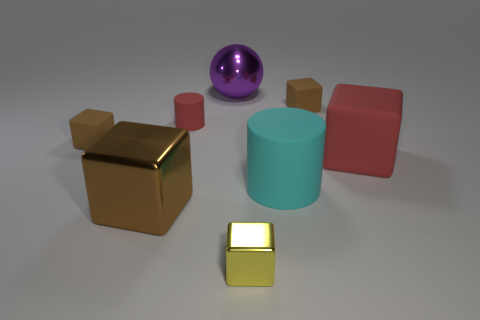Subtract all large rubber blocks. How many blocks are left? 4 Subtract all yellow blocks. How many blocks are left? 4 Subtract all spheres. How many objects are left? 7 Add 2 tiny yellow metallic blocks. How many objects exist? 10 Subtract 2 cubes. How many cubes are left? 3 Subtract 1 purple balls. How many objects are left? 7 Subtract all brown balls. Subtract all purple cubes. How many balls are left? 1 Subtract all yellow cylinders. How many red balls are left? 0 Subtract all purple rubber things. Subtract all tiny rubber things. How many objects are left? 5 Add 4 red rubber objects. How many red rubber objects are left? 6 